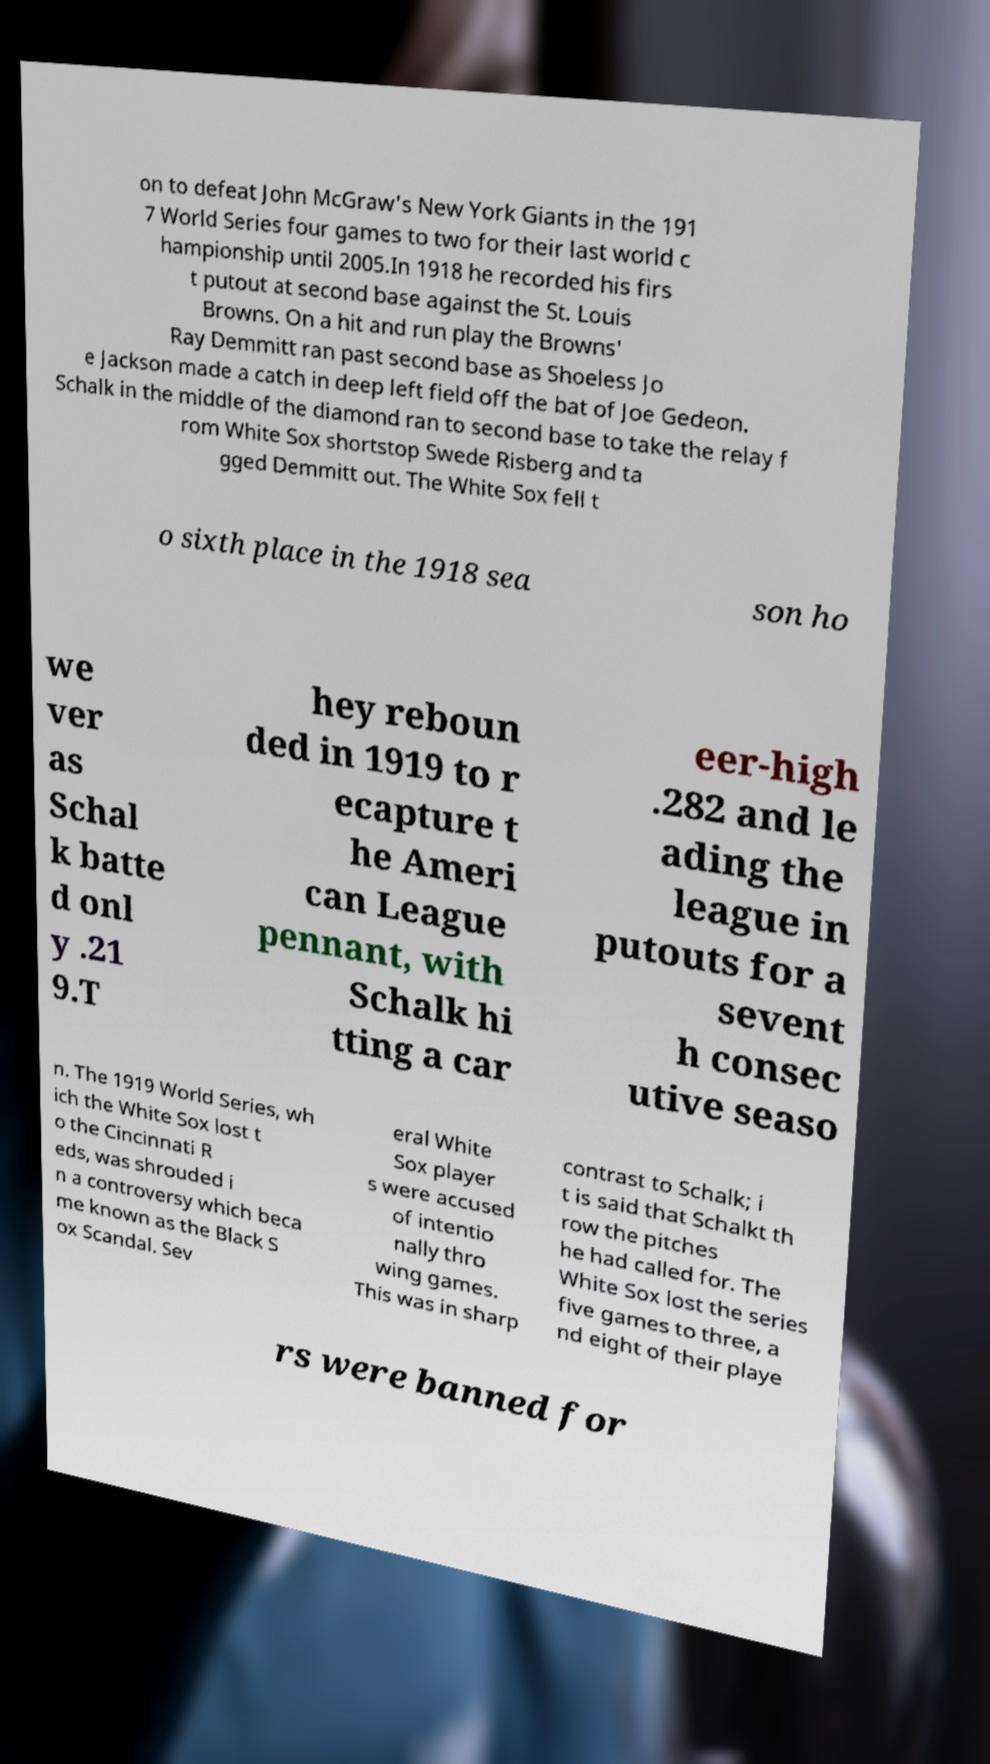Can you accurately transcribe the text from the provided image for me? on to defeat John McGraw's New York Giants in the 191 7 World Series four games to two for their last world c hampionship until 2005.In 1918 he recorded his firs t putout at second base against the St. Louis Browns. On a hit and run play the Browns' Ray Demmitt ran past second base as Shoeless Jo e Jackson made a catch in deep left field off the bat of Joe Gedeon. Schalk in the middle of the diamond ran to second base to take the relay f rom White Sox shortstop Swede Risberg and ta gged Demmitt out. The White Sox fell t o sixth place in the 1918 sea son ho we ver as Schal k batte d onl y .21 9.T hey reboun ded in 1919 to r ecapture t he Ameri can League pennant, with Schalk hi tting a car eer-high .282 and le ading the league in putouts for a sevent h consec utive seaso n. The 1919 World Series, wh ich the White Sox lost t o the Cincinnati R eds, was shrouded i n a controversy which beca me known as the Black S ox Scandal. Sev eral White Sox player s were accused of intentio nally thro wing games. This was in sharp contrast to Schalk; i t is said that Schalkt th row the pitches he had called for. The White Sox lost the series five games to three, a nd eight of their playe rs were banned for 